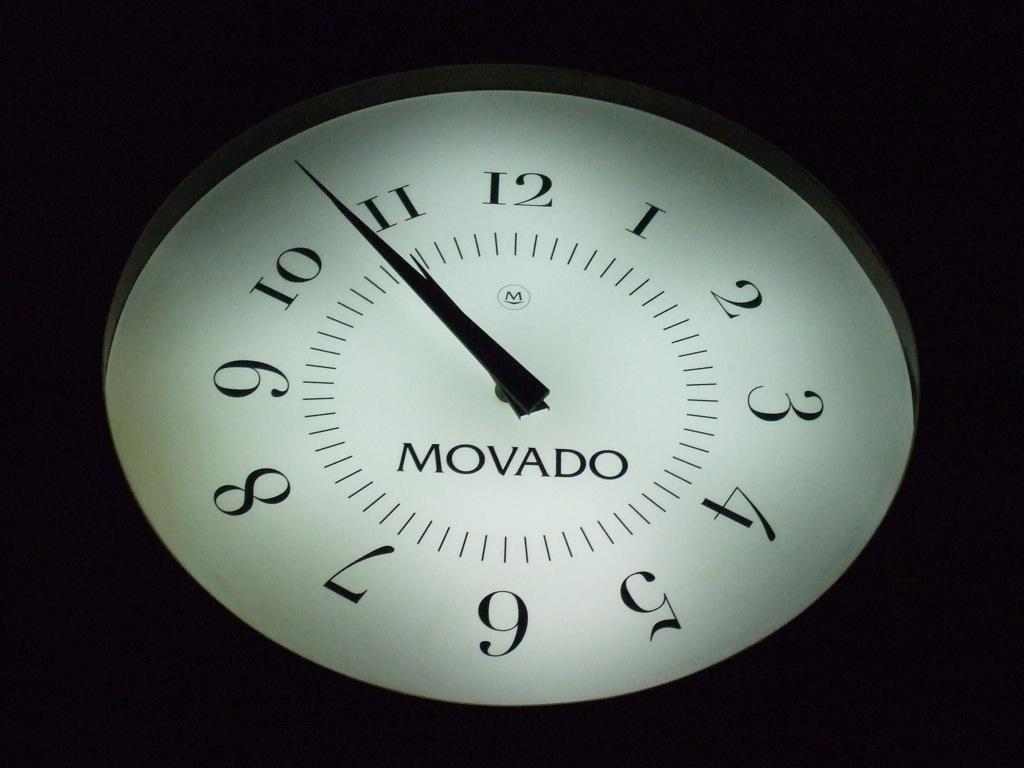<image>
Give a short and clear explanation of the subsequent image. White clock with the hands on number 11 and says Movado. 